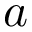<formula> <loc_0><loc_0><loc_500><loc_500>a</formula> 